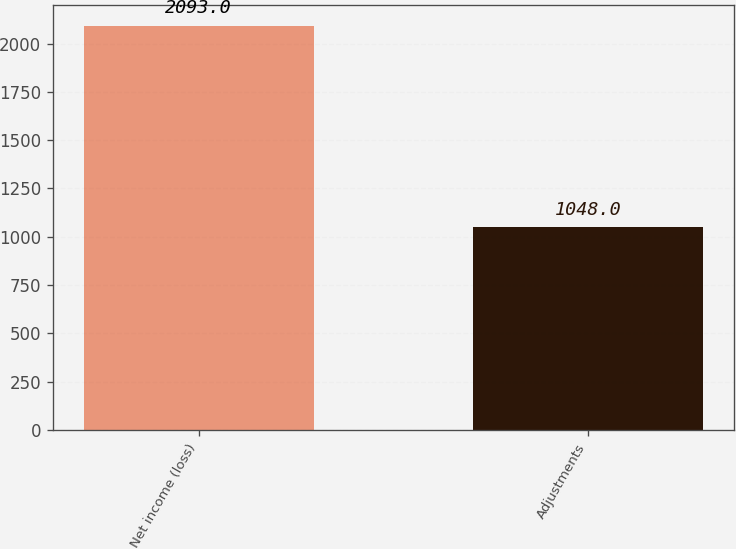<chart> <loc_0><loc_0><loc_500><loc_500><bar_chart><fcel>Net income (loss)<fcel>Adjustments<nl><fcel>2093<fcel>1048<nl></chart> 